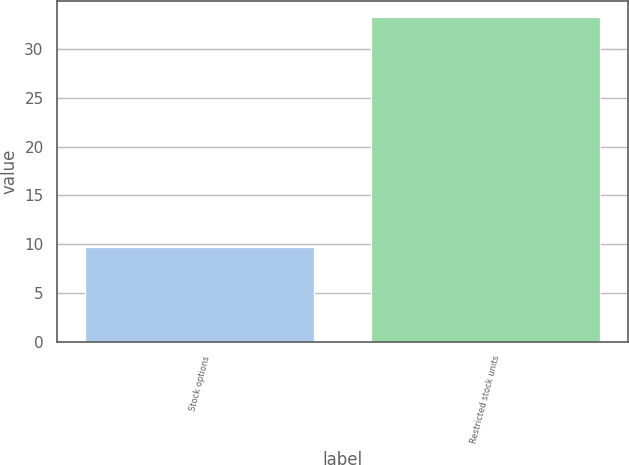<chart> <loc_0><loc_0><loc_500><loc_500><bar_chart><fcel>Stock options<fcel>Restricted stock units<nl><fcel>9.7<fcel>33.3<nl></chart> 